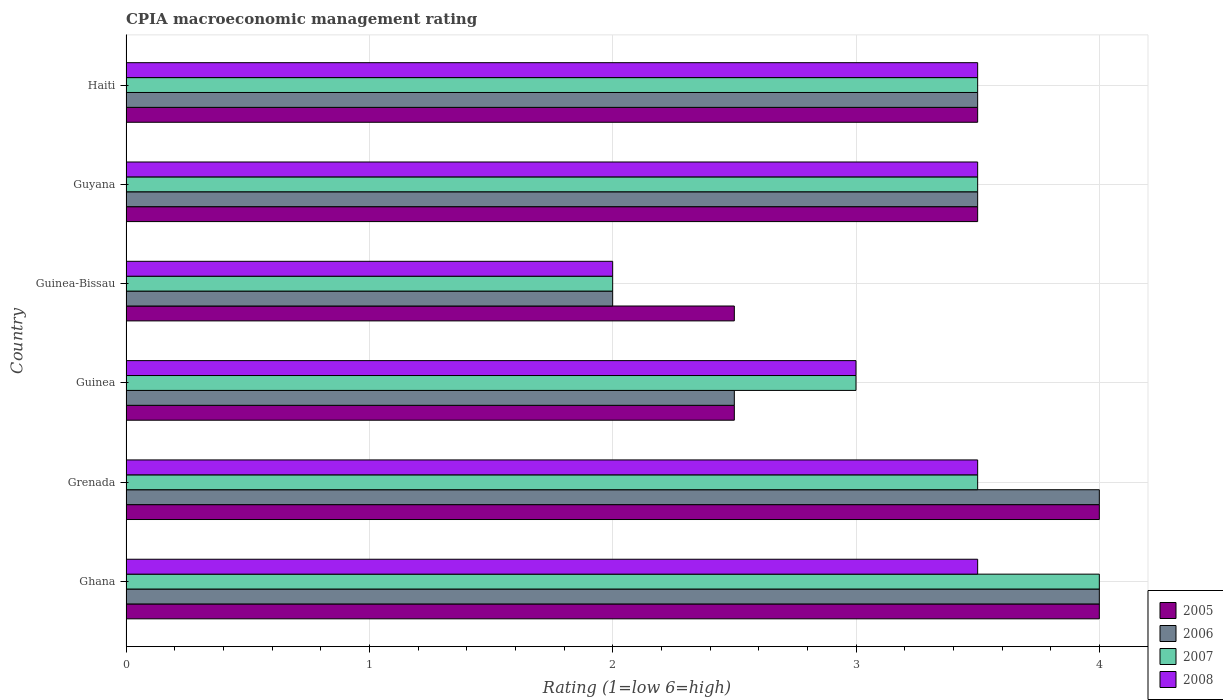How many groups of bars are there?
Your answer should be compact. 6. Are the number of bars per tick equal to the number of legend labels?
Provide a succinct answer. Yes. How many bars are there on the 4th tick from the top?
Provide a succinct answer. 4. How many bars are there on the 5th tick from the bottom?
Ensure brevity in your answer.  4. What is the label of the 1st group of bars from the top?
Make the answer very short. Haiti. In how many cases, is the number of bars for a given country not equal to the number of legend labels?
Ensure brevity in your answer.  0. What is the CPIA rating in 2005 in Ghana?
Provide a succinct answer. 4. Across all countries, what is the minimum CPIA rating in 2008?
Keep it short and to the point. 2. In which country was the CPIA rating in 2006 minimum?
Provide a short and direct response. Guinea-Bissau. What is the total CPIA rating in 2008 in the graph?
Offer a terse response. 19. What is the difference between the CPIA rating in 2008 in Ghana and the CPIA rating in 2005 in Guinea?
Ensure brevity in your answer.  1. What is the average CPIA rating in 2005 per country?
Your response must be concise. 3.33. What is the difference between the CPIA rating in 2005 and CPIA rating in 2006 in Guyana?
Provide a short and direct response. 0. In how many countries, is the CPIA rating in 2006 greater than 3.2 ?
Offer a very short reply. 4. What is the ratio of the CPIA rating in 2008 in Guinea-Bissau to that in Haiti?
Keep it short and to the point. 0.57. Is the CPIA rating in 2007 in Guinea less than that in Haiti?
Provide a short and direct response. Yes. Is the difference between the CPIA rating in 2005 in Guinea and Guinea-Bissau greater than the difference between the CPIA rating in 2006 in Guinea and Guinea-Bissau?
Offer a terse response. No. What is the difference between the highest and the second highest CPIA rating in 2005?
Keep it short and to the point. 0. What is the difference between the highest and the lowest CPIA rating in 2005?
Make the answer very short. 1.5. Is the sum of the CPIA rating in 2006 in Grenada and Guyana greater than the maximum CPIA rating in 2007 across all countries?
Give a very brief answer. Yes. Is it the case that in every country, the sum of the CPIA rating in 2008 and CPIA rating in 2005 is greater than the sum of CPIA rating in 2006 and CPIA rating in 2007?
Give a very brief answer. No. What does the 3rd bar from the top in Grenada represents?
Provide a short and direct response. 2006. Is it the case that in every country, the sum of the CPIA rating in 2008 and CPIA rating in 2006 is greater than the CPIA rating in 2007?
Provide a short and direct response. Yes. How many bars are there?
Provide a short and direct response. 24. What is the difference between two consecutive major ticks on the X-axis?
Ensure brevity in your answer.  1. Are the values on the major ticks of X-axis written in scientific E-notation?
Provide a short and direct response. No. Does the graph contain any zero values?
Make the answer very short. No. How many legend labels are there?
Keep it short and to the point. 4. How are the legend labels stacked?
Give a very brief answer. Vertical. What is the title of the graph?
Ensure brevity in your answer.  CPIA macroeconomic management rating. What is the Rating (1=low 6=high) of 2005 in Ghana?
Your response must be concise. 4. What is the Rating (1=low 6=high) in 2007 in Ghana?
Offer a terse response. 4. What is the Rating (1=low 6=high) of 2005 in Grenada?
Provide a short and direct response. 4. What is the Rating (1=low 6=high) in 2008 in Grenada?
Make the answer very short. 3.5. What is the Rating (1=low 6=high) in 2006 in Guinea?
Give a very brief answer. 2.5. What is the Rating (1=low 6=high) in 2007 in Guinea?
Your answer should be very brief. 3. What is the Rating (1=low 6=high) of 2008 in Guinea?
Your answer should be very brief. 3. What is the Rating (1=low 6=high) of 2006 in Guinea-Bissau?
Offer a terse response. 2. What is the Rating (1=low 6=high) of 2007 in Guinea-Bissau?
Provide a succinct answer. 2. What is the Rating (1=low 6=high) in 2005 in Guyana?
Provide a short and direct response. 3.5. What is the Rating (1=low 6=high) in 2006 in Guyana?
Offer a terse response. 3.5. Across all countries, what is the maximum Rating (1=low 6=high) of 2008?
Provide a succinct answer. 3.5. Across all countries, what is the minimum Rating (1=low 6=high) of 2006?
Make the answer very short. 2. Across all countries, what is the minimum Rating (1=low 6=high) of 2007?
Your response must be concise. 2. What is the total Rating (1=low 6=high) of 2005 in the graph?
Your response must be concise. 20. What is the total Rating (1=low 6=high) in 2006 in the graph?
Your response must be concise. 19.5. What is the total Rating (1=low 6=high) of 2007 in the graph?
Your answer should be very brief. 19.5. What is the difference between the Rating (1=low 6=high) in 2005 in Ghana and that in Grenada?
Give a very brief answer. 0. What is the difference between the Rating (1=low 6=high) of 2007 in Ghana and that in Grenada?
Ensure brevity in your answer.  0.5. What is the difference between the Rating (1=low 6=high) in 2008 in Ghana and that in Grenada?
Give a very brief answer. 0. What is the difference between the Rating (1=low 6=high) in 2006 in Ghana and that in Guinea?
Keep it short and to the point. 1.5. What is the difference between the Rating (1=low 6=high) in 2007 in Ghana and that in Guinea?
Provide a succinct answer. 1. What is the difference between the Rating (1=low 6=high) in 2008 in Ghana and that in Guinea?
Make the answer very short. 0.5. What is the difference between the Rating (1=low 6=high) in 2005 in Ghana and that in Guinea-Bissau?
Offer a very short reply. 1.5. What is the difference between the Rating (1=low 6=high) of 2006 in Ghana and that in Guinea-Bissau?
Give a very brief answer. 2. What is the difference between the Rating (1=low 6=high) in 2007 in Ghana and that in Guinea-Bissau?
Offer a terse response. 2. What is the difference between the Rating (1=low 6=high) of 2005 in Ghana and that in Guyana?
Keep it short and to the point. 0.5. What is the difference between the Rating (1=low 6=high) of 2007 in Ghana and that in Guyana?
Keep it short and to the point. 0.5. What is the difference between the Rating (1=low 6=high) in 2008 in Ghana and that in Guyana?
Give a very brief answer. 0. What is the difference between the Rating (1=low 6=high) in 2008 in Ghana and that in Haiti?
Provide a short and direct response. 0. What is the difference between the Rating (1=low 6=high) of 2006 in Grenada and that in Guinea?
Provide a succinct answer. 1.5. What is the difference between the Rating (1=low 6=high) in 2008 in Grenada and that in Guinea?
Your answer should be compact. 0.5. What is the difference between the Rating (1=low 6=high) in 2006 in Grenada and that in Guinea-Bissau?
Make the answer very short. 2. What is the difference between the Rating (1=low 6=high) of 2005 in Grenada and that in Guyana?
Offer a very short reply. 0.5. What is the difference between the Rating (1=low 6=high) in 2005 in Grenada and that in Haiti?
Provide a short and direct response. 0.5. What is the difference between the Rating (1=low 6=high) in 2006 in Grenada and that in Haiti?
Provide a short and direct response. 0.5. What is the difference between the Rating (1=low 6=high) of 2007 in Grenada and that in Haiti?
Offer a terse response. 0. What is the difference between the Rating (1=low 6=high) in 2008 in Grenada and that in Haiti?
Give a very brief answer. 0. What is the difference between the Rating (1=low 6=high) in 2006 in Guinea and that in Guinea-Bissau?
Your response must be concise. 0.5. What is the difference between the Rating (1=low 6=high) in 2008 in Guinea and that in Guinea-Bissau?
Offer a very short reply. 1. What is the difference between the Rating (1=low 6=high) of 2006 in Guinea and that in Guyana?
Offer a very short reply. -1. What is the difference between the Rating (1=low 6=high) of 2007 in Guinea and that in Guyana?
Keep it short and to the point. -0.5. What is the difference between the Rating (1=low 6=high) of 2005 in Guinea and that in Haiti?
Your response must be concise. -1. What is the difference between the Rating (1=low 6=high) of 2006 in Guinea and that in Haiti?
Ensure brevity in your answer.  -1. What is the difference between the Rating (1=low 6=high) in 2007 in Guinea and that in Haiti?
Ensure brevity in your answer.  -0.5. What is the difference between the Rating (1=low 6=high) of 2008 in Guinea and that in Haiti?
Your response must be concise. -0.5. What is the difference between the Rating (1=low 6=high) in 2005 in Guinea-Bissau and that in Guyana?
Offer a very short reply. -1. What is the difference between the Rating (1=low 6=high) of 2008 in Guinea-Bissau and that in Guyana?
Give a very brief answer. -1.5. What is the difference between the Rating (1=low 6=high) in 2006 in Guinea-Bissau and that in Haiti?
Your answer should be very brief. -1.5. What is the difference between the Rating (1=low 6=high) of 2007 in Guinea-Bissau and that in Haiti?
Give a very brief answer. -1.5. What is the difference between the Rating (1=low 6=high) in 2006 in Guyana and that in Haiti?
Your response must be concise. 0. What is the difference between the Rating (1=low 6=high) in 2007 in Guyana and that in Haiti?
Your answer should be very brief. 0. What is the difference between the Rating (1=low 6=high) in 2005 in Ghana and the Rating (1=low 6=high) in 2006 in Grenada?
Your answer should be compact. 0. What is the difference between the Rating (1=low 6=high) in 2005 in Ghana and the Rating (1=low 6=high) in 2007 in Grenada?
Make the answer very short. 0.5. What is the difference between the Rating (1=low 6=high) in 2005 in Ghana and the Rating (1=low 6=high) in 2008 in Grenada?
Offer a very short reply. 0.5. What is the difference between the Rating (1=low 6=high) in 2006 in Ghana and the Rating (1=low 6=high) in 2007 in Grenada?
Give a very brief answer. 0.5. What is the difference between the Rating (1=low 6=high) of 2007 in Ghana and the Rating (1=low 6=high) of 2008 in Guinea?
Offer a very short reply. 1. What is the difference between the Rating (1=low 6=high) in 2005 in Ghana and the Rating (1=low 6=high) in 2008 in Guinea-Bissau?
Your answer should be very brief. 2. What is the difference between the Rating (1=low 6=high) in 2006 in Ghana and the Rating (1=low 6=high) in 2007 in Guinea-Bissau?
Offer a terse response. 2. What is the difference between the Rating (1=low 6=high) in 2006 in Ghana and the Rating (1=low 6=high) in 2008 in Guinea-Bissau?
Your answer should be compact. 2. What is the difference between the Rating (1=low 6=high) in 2007 in Ghana and the Rating (1=low 6=high) in 2008 in Guinea-Bissau?
Make the answer very short. 2. What is the difference between the Rating (1=low 6=high) of 2005 in Ghana and the Rating (1=low 6=high) of 2006 in Guyana?
Your answer should be very brief. 0.5. What is the difference between the Rating (1=low 6=high) in 2005 in Ghana and the Rating (1=low 6=high) in 2008 in Guyana?
Your answer should be compact. 0.5. What is the difference between the Rating (1=low 6=high) of 2006 in Ghana and the Rating (1=low 6=high) of 2007 in Guyana?
Offer a very short reply. 0.5. What is the difference between the Rating (1=low 6=high) in 2007 in Ghana and the Rating (1=low 6=high) in 2008 in Guyana?
Offer a terse response. 0.5. What is the difference between the Rating (1=low 6=high) in 2005 in Ghana and the Rating (1=low 6=high) in 2006 in Haiti?
Offer a very short reply. 0.5. What is the difference between the Rating (1=low 6=high) of 2005 in Ghana and the Rating (1=low 6=high) of 2007 in Haiti?
Provide a succinct answer. 0.5. What is the difference between the Rating (1=low 6=high) of 2005 in Ghana and the Rating (1=low 6=high) of 2008 in Haiti?
Your response must be concise. 0.5. What is the difference between the Rating (1=low 6=high) of 2006 in Ghana and the Rating (1=low 6=high) of 2007 in Haiti?
Your response must be concise. 0.5. What is the difference between the Rating (1=low 6=high) of 2006 in Ghana and the Rating (1=low 6=high) of 2008 in Haiti?
Your response must be concise. 0.5. What is the difference between the Rating (1=low 6=high) in 2007 in Ghana and the Rating (1=low 6=high) in 2008 in Haiti?
Your response must be concise. 0.5. What is the difference between the Rating (1=low 6=high) of 2005 in Grenada and the Rating (1=low 6=high) of 2006 in Guinea?
Offer a terse response. 1.5. What is the difference between the Rating (1=low 6=high) in 2005 in Grenada and the Rating (1=low 6=high) in 2007 in Guinea?
Offer a terse response. 1. What is the difference between the Rating (1=low 6=high) in 2006 in Grenada and the Rating (1=low 6=high) in 2007 in Guinea?
Offer a terse response. 1. What is the difference between the Rating (1=low 6=high) of 2007 in Grenada and the Rating (1=low 6=high) of 2008 in Guinea?
Offer a very short reply. 0.5. What is the difference between the Rating (1=low 6=high) in 2005 in Grenada and the Rating (1=low 6=high) in 2008 in Guinea-Bissau?
Offer a terse response. 2. What is the difference between the Rating (1=low 6=high) in 2006 in Grenada and the Rating (1=low 6=high) in 2008 in Guinea-Bissau?
Give a very brief answer. 2. What is the difference between the Rating (1=low 6=high) in 2007 in Grenada and the Rating (1=low 6=high) in 2008 in Guinea-Bissau?
Provide a succinct answer. 1.5. What is the difference between the Rating (1=low 6=high) of 2005 in Grenada and the Rating (1=low 6=high) of 2007 in Guyana?
Provide a short and direct response. 0.5. What is the difference between the Rating (1=low 6=high) in 2005 in Grenada and the Rating (1=low 6=high) in 2008 in Guyana?
Offer a very short reply. 0.5. What is the difference between the Rating (1=low 6=high) in 2005 in Grenada and the Rating (1=low 6=high) in 2007 in Haiti?
Ensure brevity in your answer.  0.5. What is the difference between the Rating (1=low 6=high) in 2006 in Grenada and the Rating (1=low 6=high) in 2007 in Haiti?
Keep it short and to the point. 0.5. What is the difference between the Rating (1=low 6=high) in 2006 in Grenada and the Rating (1=low 6=high) in 2008 in Haiti?
Offer a terse response. 0.5. What is the difference between the Rating (1=low 6=high) of 2007 in Grenada and the Rating (1=low 6=high) of 2008 in Haiti?
Make the answer very short. 0. What is the difference between the Rating (1=low 6=high) in 2005 in Guinea and the Rating (1=low 6=high) in 2006 in Guinea-Bissau?
Provide a succinct answer. 0.5. What is the difference between the Rating (1=low 6=high) of 2005 in Guinea and the Rating (1=low 6=high) of 2006 in Guyana?
Give a very brief answer. -1. What is the difference between the Rating (1=low 6=high) in 2005 in Guinea and the Rating (1=low 6=high) in 2007 in Guyana?
Provide a succinct answer. -1. What is the difference between the Rating (1=low 6=high) in 2006 in Guinea and the Rating (1=low 6=high) in 2007 in Guyana?
Provide a succinct answer. -1. What is the difference between the Rating (1=low 6=high) in 2007 in Guinea and the Rating (1=low 6=high) in 2008 in Guyana?
Keep it short and to the point. -0.5. What is the difference between the Rating (1=low 6=high) of 2005 in Guinea and the Rating (1=low 6=high) of 2008 in Haiti?
Offer a terse response. -1. What is the difference between the Rating (1=low 6=high) of 2006 in Guinea and the Rating (1=low 6=high) of 2007 in Haiti?
Give a very brief answer. -1. What is the difference between the Rating (1=low 6=high) in 2006 in Guinea and the Rating (1=low 6=high) in 2008 in Haiti?
Offer a very short reply. -1. What is the difference between the Rating (1=low 6=high) in 2005 in Guinea-Bissau and the Rating (1=low 6=high) in 2006 in Guyana?
Your answer should be compact. -1. What is the difference between the Rating (1=low 6=high) of 2006 in Guinea-Bissau and the Rating (1=low 6=high) of 2007 in Guyana?
Offer a terse response. -1.5. What is the difference between the Rating (1=low 6=high) in 2006 in Guinea-Bissau and the Rating (1=low 6=high) in 2007 in Haiti?
Give a very brief answer. -1.5. What is the difference between the Rating (1=low 6=high) in 2006 in Guinea-Bissau and the Rating (1=low 6=high) in 2008 in Haiti?
Keep it short and to the point. -1.5. What is the difference between the Rating (1=low 6=high) in 2007 in Guinea-Bissau and the Rating (1=low 6=high) in 2008 in Haiti?
Ensure brevity in your answer.  -1.5. What is the difference between the Rating (1=low 6=high) in 2005 in Guyana and the Rating (1=low 6=high) in 2006 in Haiti?
Offer a very short reply. 0. What is the difference between the Rating (1=low 6=high) of 2005 in Guyana and the Rating (1=low 6=high) of 2008 in Haiti?
Ensure brevity in your answer.  0. What is the difference between the Rating (1=low 6=high) of 2006 in Guyana and the Rating (1=low 6=high) of 2008 in Haiti?
Ensure brevity in your answer.  0. What is the average Rating (1=low 6=high) of 2008 per country?
Make the answer very short. 3.17. What is the difference between the Rating (1=low 6=high) of 2005 and Rating (1=low 6=high) of 2006 in Ghana?
Your answer should be compact. 0. What is the difference between the Rating (1=low 6=high) in 2005 and Rating (1=low 6=high) in 2008 in Ghana?
Your response must be concise. 0.5. What is the difference between the Rating (1=low 6=high) of 2006 and Rating (1=low 6=high) of 2008 in Ghana?
Make the answer very short. 0.5. What is the difference between the Rating (1=low 6=high) in 2005 and Rating (1=low 6=high) in 2007 in Grenada?
Your answer should be compact. 0.5. What is the difference between the Rating (1=low 6=high) of 2005 and Rating (1=low 6=high) of 2008 in Grenada?
Give a very brief answer. 0.5. What is the difference between the Rating (1=low 6=high) in 2005 and Rating (1=low 6=high) in 2007 in Guinea?
Your response must be concise. -0.5. What is the difference between the Rating (1=low 6=high) in 2005 and Rating (1=low 6=high) in 2008 in Guinea?
Provide a short and direct response. -0.5. What is the difference between the Rating (1=low 6=high) in 2006 and Rating (1=low 6=high) in 2008 in Guinea?
Your response must be concise. -0.5. What is the difference between the Rating (1=low 6=high) in 2007 and Rating (1=low 6=high) in 2008 in Guinea?
Make the answer very short. 0. What is the difference between the Rating (1=low 6=high) in 2006 and Rating (1=low 6=high) in 2008 in Guinea-Bissau?
Provide a succinct answer. 0. What is the difference between the Rating (1=low 6=high) of 2005 and Rating (1=low 6=high) of 2006 in Guyana?
Provide a succinct answer. 0. What is the difference between the Rating (1=low 6=high) of 2005 and Rating (1=low 6=high) of 2008 in Guyana?
Keep it short and to the point. 0. What is the difference between the Rating (1=low 6=high) in 2006 and Rating (1=low 6=high) in 2008 in Guyana?
Provide a succinct answer. 0. What is the difference between the Rating (1=low 6=high) in 2007 and Rating (1=low 6=high) in 2008 in Guyana?
Provide a short and direct response. 0. What is the difference between the Rating (1=low 6=high) of 2005 and Rating (1=low 6=high) of 2006 in Haiti?
Keep it short and to the point. 0. What is the difference between the Rating (1=low 6=high) in 2006 and Rating (1=low 6=high) in 2007 in Haiti?
Make the answer very short. 0. What is the difference between the Rating (1=low 6=high) of 2006 and Rating (1=low 6=high) of 2008 in Haiti?
Provide a short and direct response. 0. What is the difference between the Rating (1=low 6=high) of 2007 and Rating (1=low 6=high) of 2008 in Haiti?
Your answer should be compact. 0. What is the ratio of the Rating (1=low 6=high) of 2005 in Ghana to that in Grenada?
Make the answer very short. 1. What is the ratio of the Rating (1=low 6=high) of 2006 in Ghana to that in Grenada?
Your answer should be very brief. 1. What is the ratio of the Rating (1=low 6=high) in 2005 in Ghana to that in Guinea?
Ensure brevity in your answer.  1.6. What is the ratio of the Rating (1=low 6=high) of 2006 in Ghana to that in Guinea?
Your answer should be compact. 1.6. What is the ratio of the Rating (1=low 6=high) in 2007 in Ghana to that in Guinea?
Ensure brevity in your answer.  1.33. What is the ratio of the Rating (1=low 6=high) in 2005 in Ghana to that in Guinea-Bissau?
Offer a terse response. 1.6. What is the ratio of the Rating (1=low 6=high) in 2005 in Ghana to that in Guyana?
Your answer should be very brief. 1.14. What is the ratio of the Rating (1=low 6=high) of 2008 in Ghana to that in Guyana?
Make the answer very short. 1. What is the ratio of the Rating (1=low 6=high) in 2005 in Ghana to that in Haiti?
Your response must be concise. 1.14. What is the ratio of the Rating (1=low 6=high) of 2006 in Ghana to that in Haiti?
Keep it short and to the point. 1.14. What is the ratio of the Rating (1=low 6=high) in 2007 in Ghana to that in Haiti?
Offer a very short reply. 1.14. What is the ratio of the Rating (1=low 6=high) in 2008 in Ghana to that in Haiti?
Make the answer very short. 1. What is the ratio of the Rating (1=low 6=high) in 2007 in Grenada to that in Guinea?
Offer a very short reply. 1.17. What is the ratio of the Rating (1=low 6=high) in 2008 in Grenada to that in Guinea?
Ensure brevity in your answer.  1.17. What is the ratio of the Rating (1=low 6=high) of 2005 in Grenada to that in Guinea-Bissau?
Offer a very short reply. 1.6. What is the ratio of the Rating (1=low 6=high) in 2006 in Grenada to that in Guinea-Bissau?
Give a very brief answer. 2. What is the ratio of the Rating (1=low 6=high) in 2005 in Grenada to that in Guyana?
Offer a very short reply. 1.14. What is the ratio of the Rating (1=low 6=high) of 2005 in Guinea to that in Guinea-Bissau?
Give a very brief answer. 1. What is the ratio of the Rating (1=low 6=high) of 2006 in Guinea to that in Guinea-Bissau?
Ensure brevity in your answer.  1.25. What is the ratio of the Rating (1=low 6=high) in 2007 in Guinea to that in Guinea-Bissau?
Make the answer very short. 1.5. What is the ratio of the Rating (1=low 6=high) of 2008 in Guinea to that in Guinea-Bissau?
Your answer should be very brief. 1.5. What is the ratio of the Rating (1=low 6=high) of 2005 in Guinea to that in Guyana?
Your response must be concise. 0.71. What is the ratio of the Rating (1=low 6=high) of 2007 in Guinea to that in Guyana?
Your response must be concise. 0.86. What is the ratio of the Rating (1=low 6=high) in 2008 in Guinea to that in Guyana?
Offer a terse response. 0.86. What is the ratio of the Rating (1=low 6=high) of 2005 in Guinea to that in Haiti?
Ensure brevity in your answer.  0.71. What is the ratio of the Rating (1=low 6=high) in 2006 in Guinea to that in Haiti?
Offer a very short reply. 0.71. What is the ratio of the Rating (1=low 6=high) of 2007 in Guinea to that in Haiti?
Keep it short and to the point. 0.86. What is the ratio of the Rating (1=low 6=high) in 2008 in Guinea to that in Haiti?
Give a very brief answer. 0.86. What is the ratio of the Rating (1=low 6=high) of 2007 in Guinea-Bissau to that in Guyana?
Provide a succinct answer. 0.57. What is the ratio of the Rating (1=low 6=high) of 2007 in Guinea-Bissau to that in Haiti?
Your response must be concise. 0.57. What is the ratio of the Rating (1=low 6=high) in 2008 in Guinea-Bissau to that in Haiti?
Give a very brief answer. 0.57. What is the ratio of the Rating (1=low 6=high) in 2005 in Guyana to that in Haiti?
Your response must be concise. 1. What is the ratio of the Rating (1=low 6=high) of 2006 in Guyana to that in Haiti?
Your answer should be very brief. 1. What is the ratio of the Rating (1=low 6=high) in 2007 in Guyana to that in Haiti?
Your response must be concise. 1. What is the difference between the highest and the second highest Rating (1=low 6=high) of 2005?
Your answer should be very brief. 0. What is the difference between the highest and the second highest Rating (1=low 6=high) of 2006?
Offer a very short reply. 0. What is the difference between the highest and the second highest Rating (1=low 6=high) of 2007?
Offer a very short reply. 0.5. What is the difference between the highest and the second highest Rating (1=low 6=high) in 2008?
Give a very brief answer. 0. What is the difference between the highest and the lowest Rating (1=low 6=high) of 2006?
Your answer should be compact. 2. What is the difference between the highest and the lowest Rating (1=low 6=high) of 2008?
Your response must be concise. 1.5. 